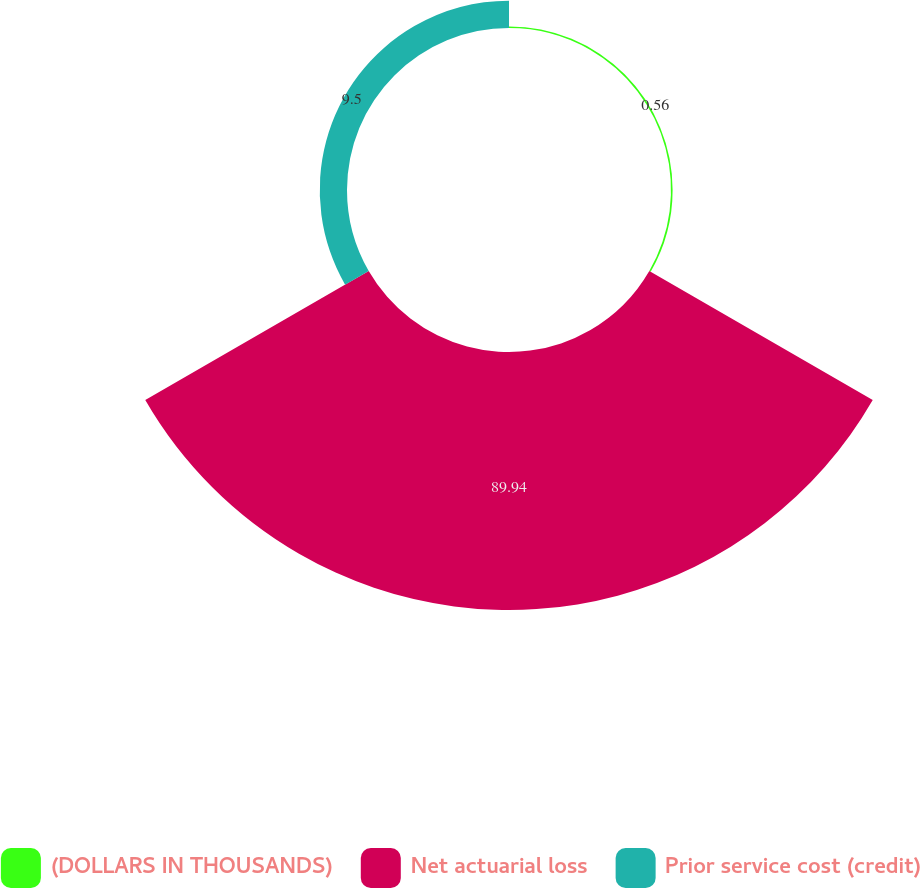Convert chart to OTSL. <chart><loc_0><loc_0><loc_500><loc_500><pie_chart><fcel>(DOLLARS IN THOUSANDS)<fcel>Net actuarial loss<fcel>Prior service cost (credit)<nl><fcel>0.56%<fcel>89.94%<fcel>9.5%<nl></chart> 